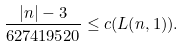<formula> <loc_0><loc_0><loc_500><loc_500>\frac { | n | - 3 } { 6 2 7 4 1 9 5 2 0 } \leq c ( L ( n , 1 ) ) .</formula> 